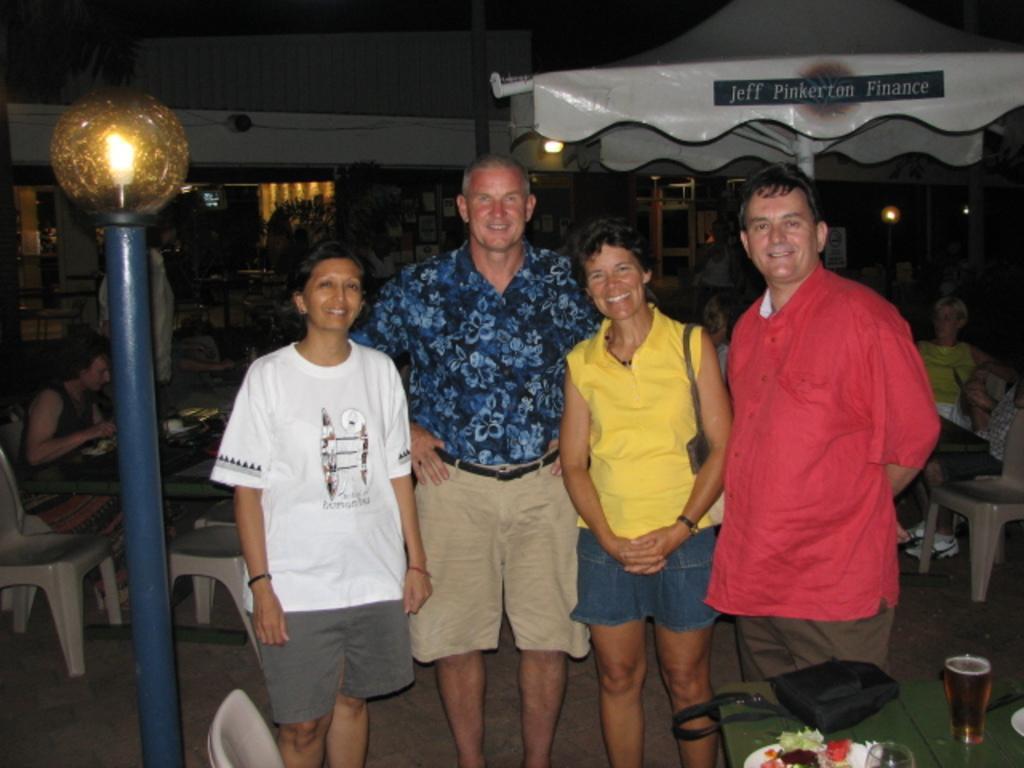Can you describe this image briefly? In this image we can see these people are standing here and smiling. The background of the image is dark, where we can see tables, chairs, a few things kept on the table, we can see the light pole and tents in the background. 